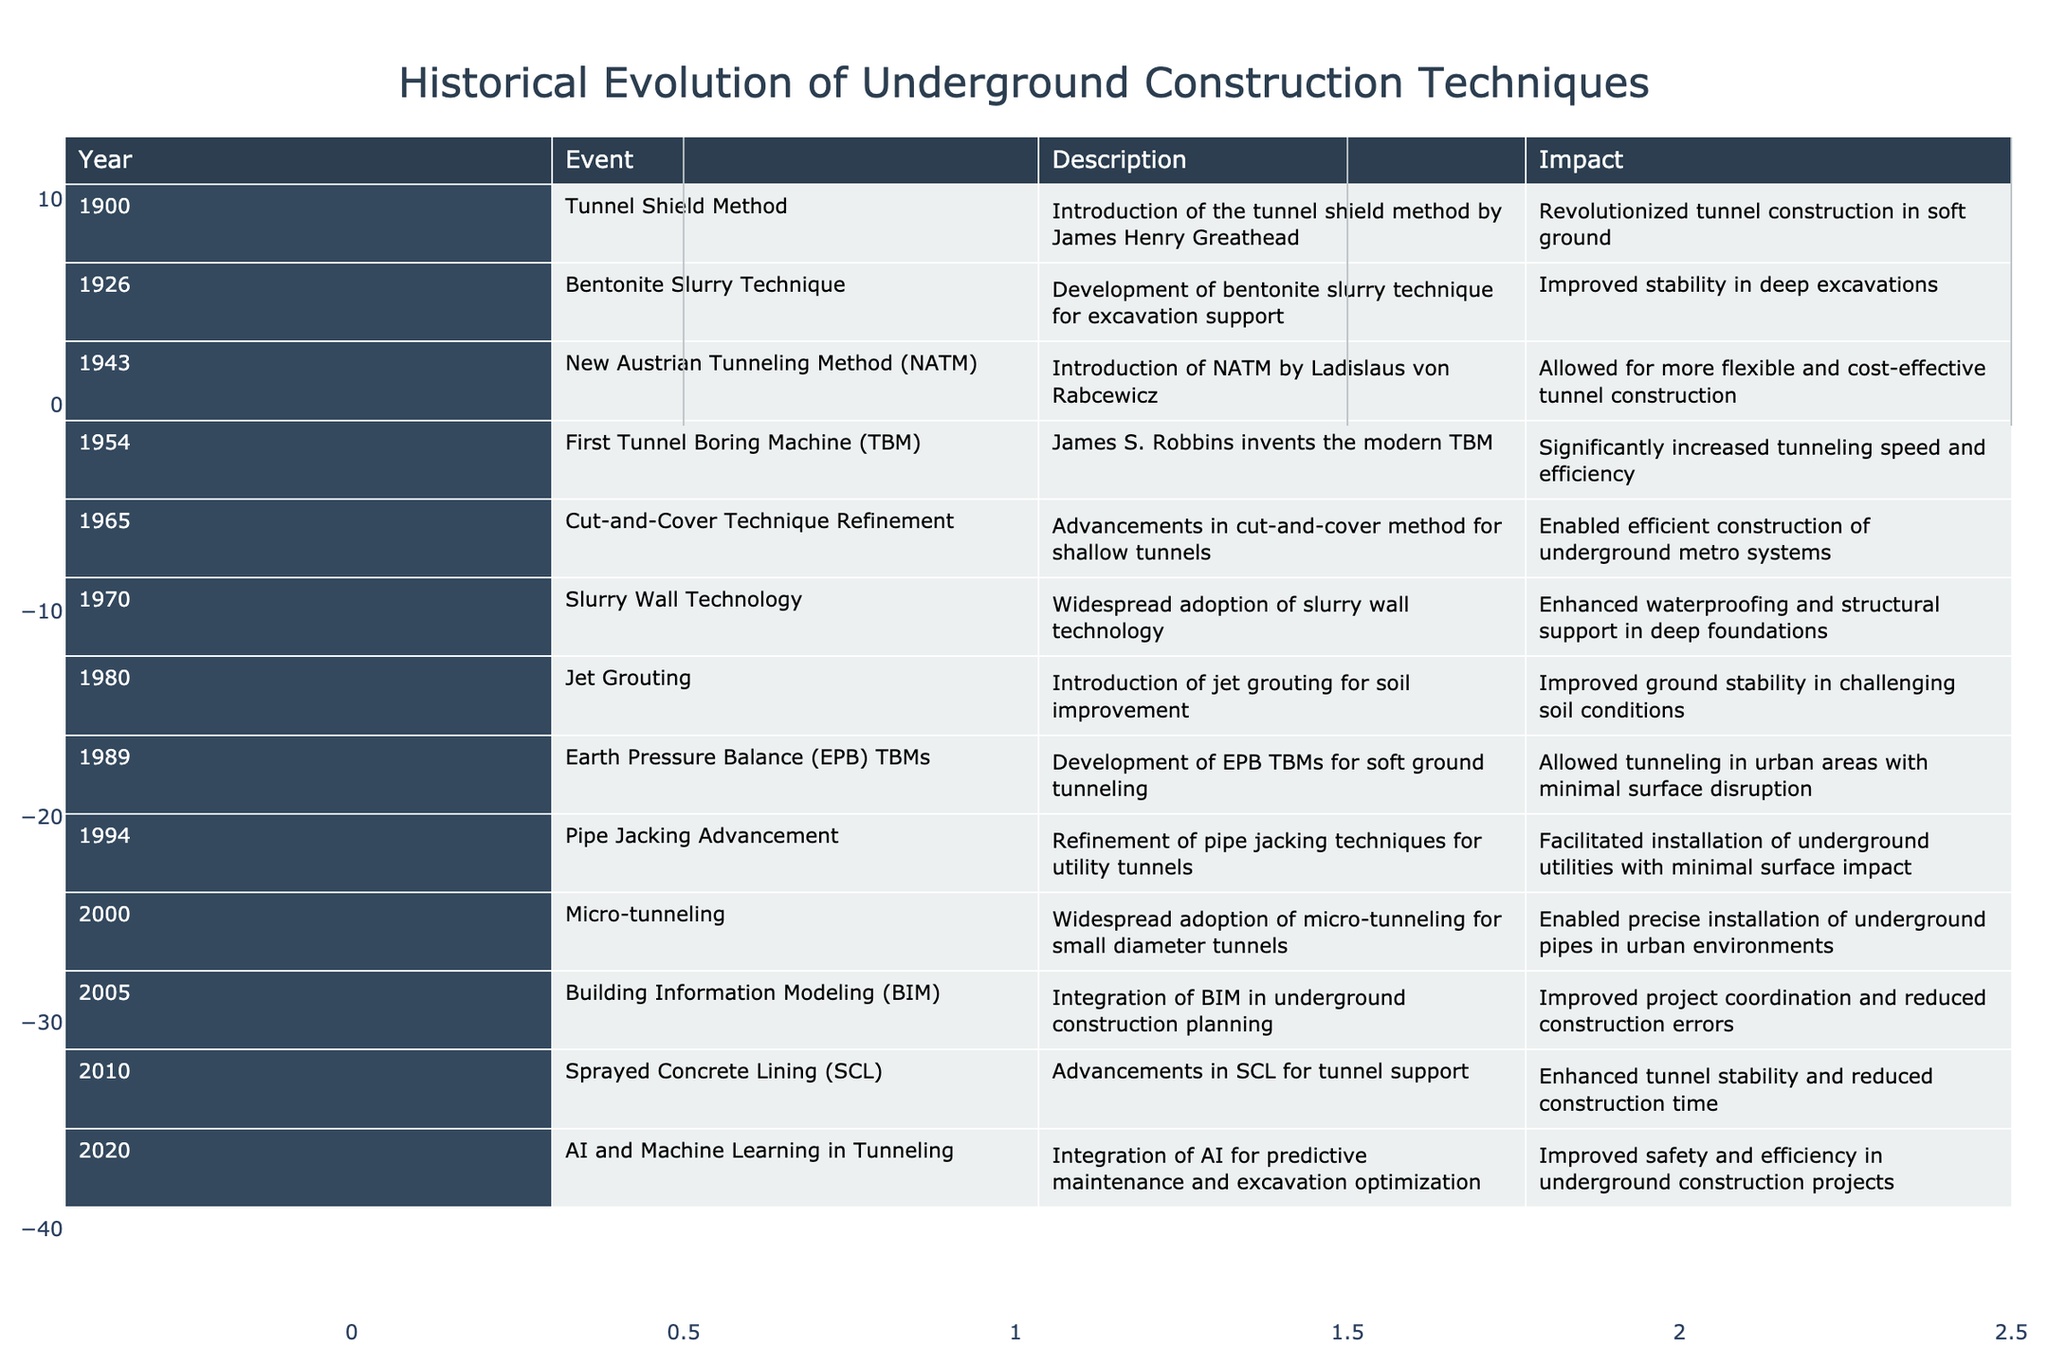What year was the first Tunnel Boring Machine invented? According to the table, the first Tunnel Boring Machine was invented in 1954.
Answer: 1954 Which technique introduced in 1943 allowed for more flexible tunnel construction? The table states that the New Austrian Tunneling Method (NATM) was introduced in 1943 and it allowed for more flexible and cost-effective tunnel construction.
Answer: New Austrian Tunneling Method (NATM) Was the introduction of jet grouting in 1980 aimed at improving ground stability? Yes, the table describes the introduction of jet grouting in 1980 as having improved ground stability in challenging soil conditions.
Answer: Yes What advancements occurred in underground construction techniques between 1965 and 1970? The table shows that from 1965 to 1970, the cut-and-cover technique was refined in 1965 and slurry wall technology was adopted in 1970, enhancing construction methods for shallow tunnels and deep foundations, respectively.
Answer: Cut-and-Cover Technique Refinement in 1965 and Slurry Wall Technology in 1970 How many techniques were developed after 2000? The table lists three techniques developed after 2000: micro-tunneling in 2000, Building Information Modeling (BIM) in 2005, and AI and Machine Learning in Tunneling in 2020. The total count is three techniques.
Answer: 3 Which method improved construction efficiency in urban areas and when was it developed? The Earth Pressure Balance (EPB) TBMs allowed tunneling in urban areas with minimal surface disruption and was developed in 1989, according to the table.
Answer: Earth Pressure Balance (EPB) TBMs in 1989 What is the impact of Building Information Modeling (BIM) introduced in 2005? The table indicates that the integration of Building Information Modeling (BIM) in underground construction planning improved project coordination and reduced construction errors, enhancing overall project efficiency.
Answer: Improved project coordination and reduced construction errors Which technique from 1970 enhanced waterproofing in deep foundations? According to the table, slurry wall technology was widely adopted in 1970 to enhance waterproofing and structural support in deep foundations.
Answer: Slurry Wall Technology How many events listed support improvements in excavation stability or efficiency? The table indicates several events that support improvements in excavation: bentonite slurry technique (1926), jet grouting (1980), and AI and Machine Learning (2020). Summing these, there are three distinct advancements tied to stability or efficiency in excavation practices based on the listed events.
Answer: 3 